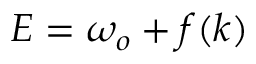Convert formula to latex. <formula><loc_0><loc_0><loc_500><loc_500>E = \omega _ { o } + f ( k )</formula> 